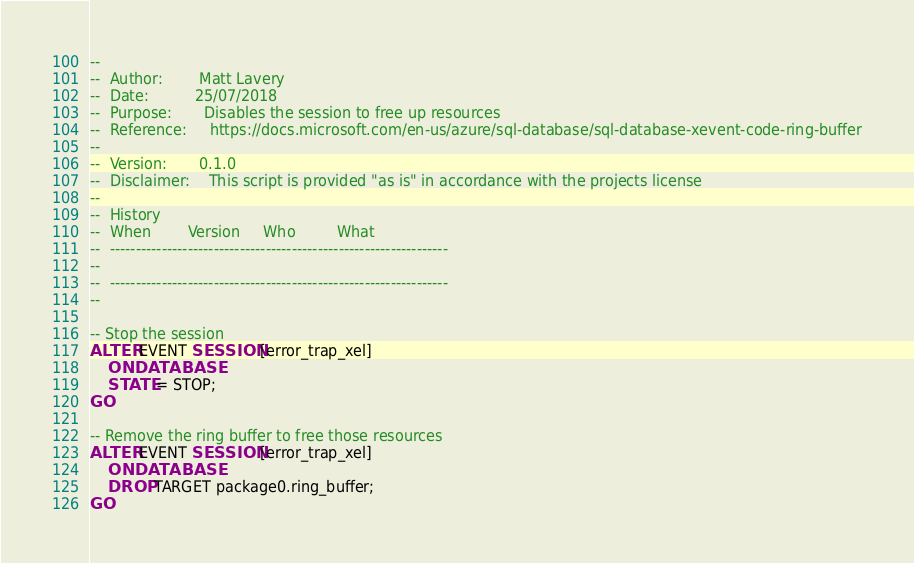<code> <loc_0><loc_0><loc_500><loc_500><_SQL_>--
--  Author:        Matt Lavery
--  Date:          25/07/2018
--  Purpose:       Disables the session to free up resources
--  Reference:     https://docs.microsoft.com/en-us/azure/sql-database/sql-database-xevent-code-ring-buffer
-- 
--  Version:       0.1.0 
--  Disclaimer:    This script is provided "as is" in accordance with the projects license
--
--  History
--  When        Version     Who         What
--  -----------------------------------------------------------------
--
--  -----------------------------------------------------------------
--

-- Stop the session
ALTER EVENT SESSION [error_trap_xel]
    ON DATABASE
    STATE = STOP;
GO

-- Remove the ring buffer to free those resources
ALTER EVENT SESSION [error_trap_xel]
    ON DATABASE
    DROP TARGET package0.ring_buffer;
GO
</code> 